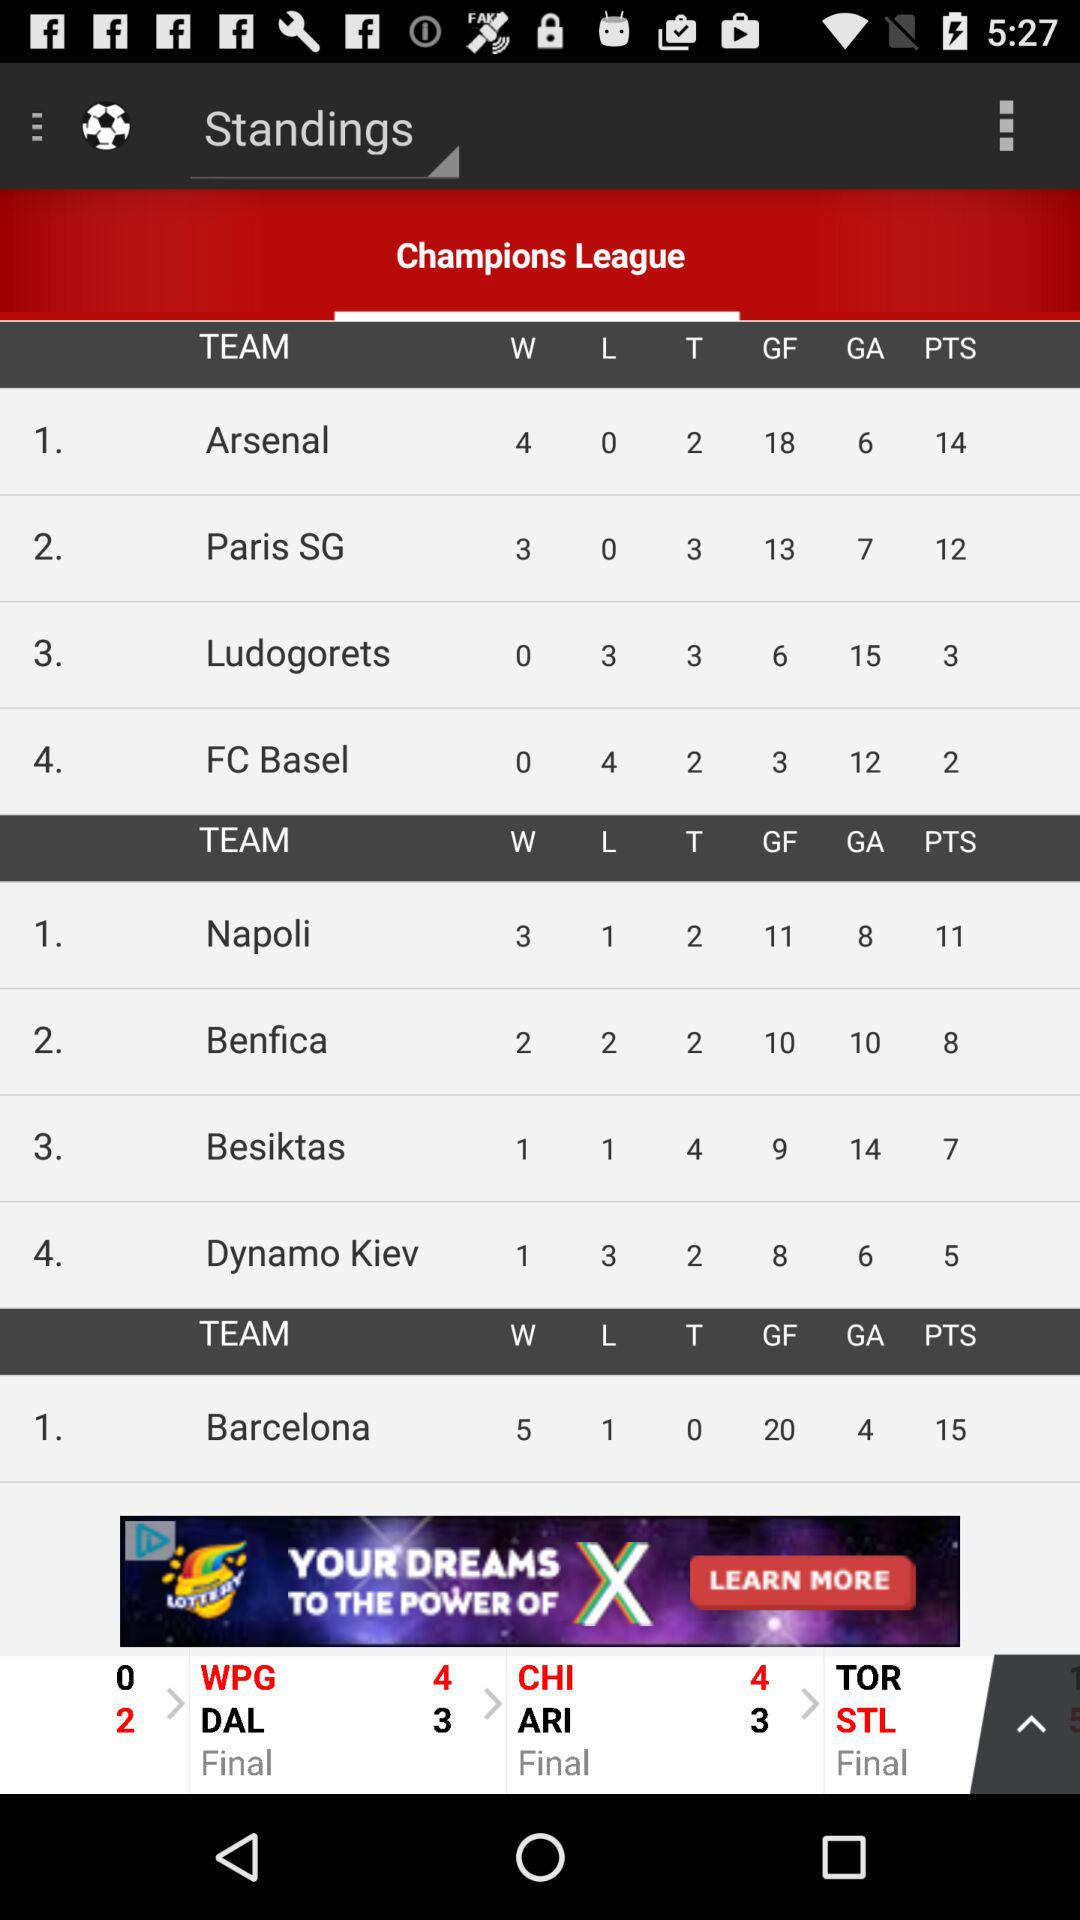How many more goals does Arsenal have than Ludogorets?
Answer the question using a single word or phrase. 12 